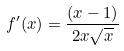<formula> <loc_0><loc_0><loc_500><loc_500>f ^ { \prime } ( x ) = \frac { ( x - 1 ) } { 2 x \sqrt { x } }</formula> 